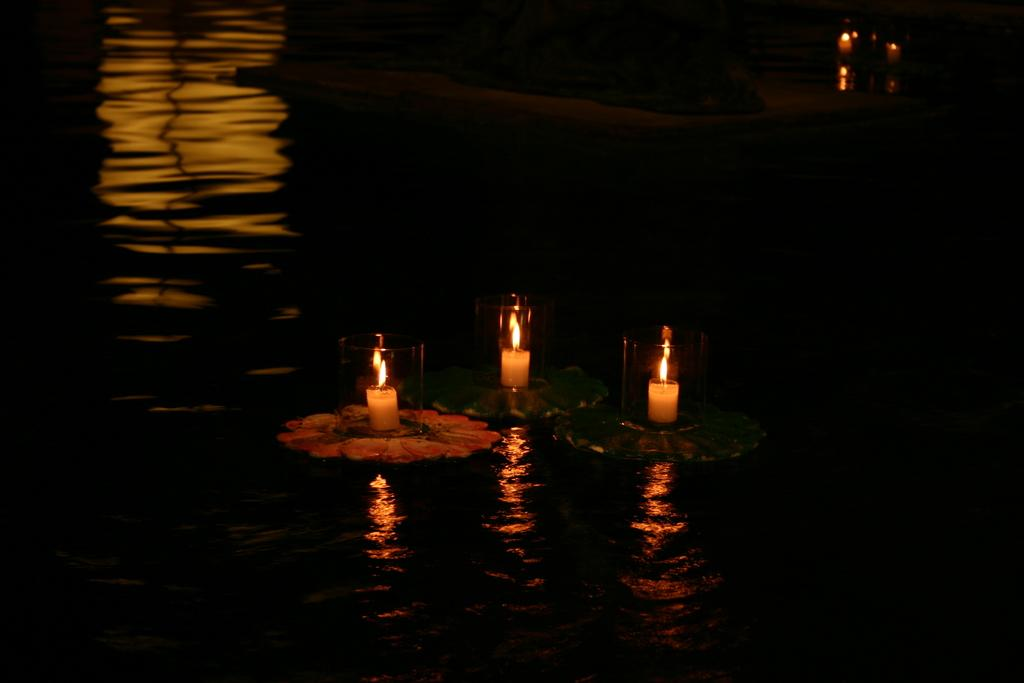What is burning in the image? There are candles with flames in the image. How are the candles contained in the image? The candles are in glass objects. What are the glass objects placed on in the image? The objects are on water. Can you describe the appearance of the candles in the image? The candles are burning with flames in the glass objects. What type of pickle is floating in the water next to the candles? There is no pickle present in the image; the objects on water are glass containers holding candles. 